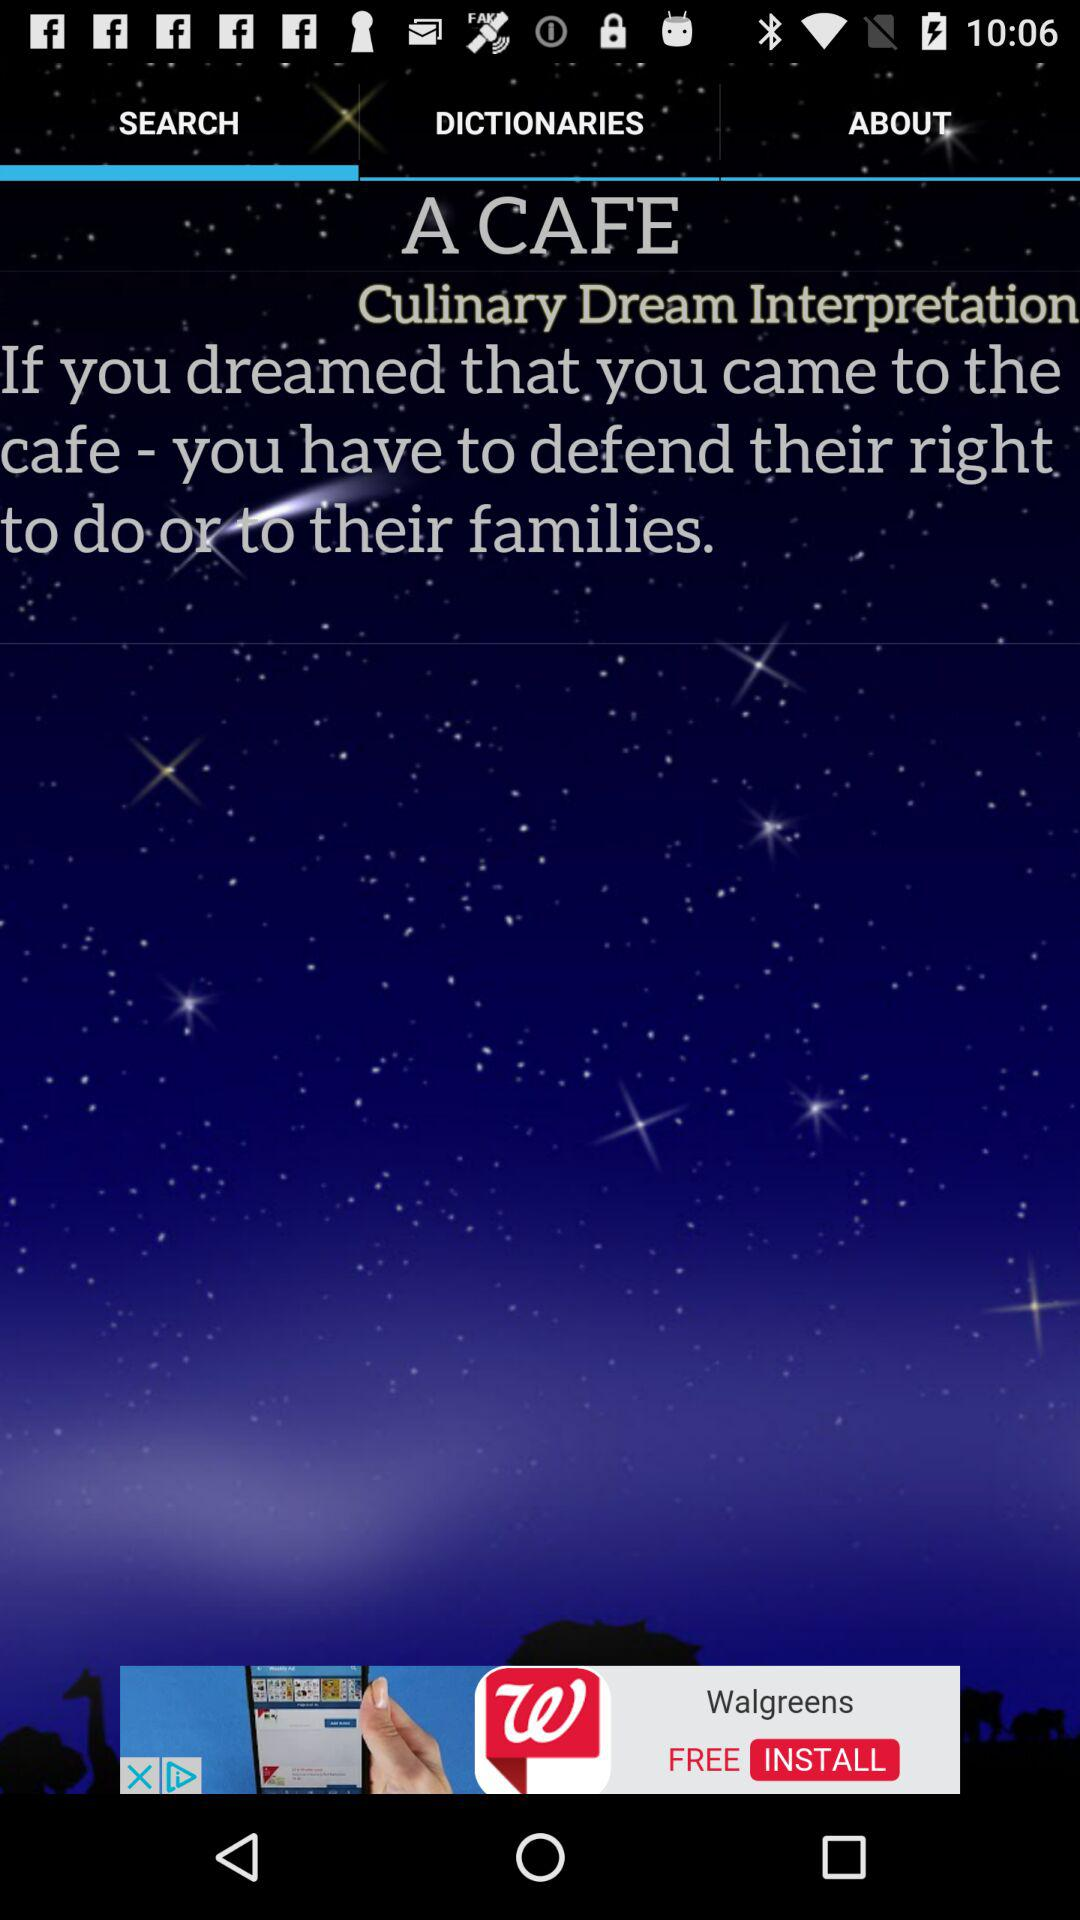Which tab is selected? The selected tab is "SEARCH". 